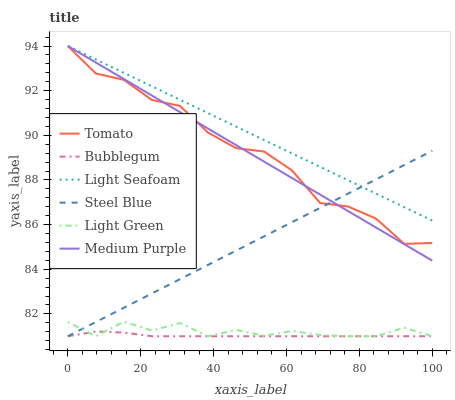Does Bubblegum have the minimum area under the curve?
Answer yes or no. Yes. Does Light Seafoam have the maximum area under the curve?
Answer yes or no. Yes. Does Steel Blue have the minimum area under the curve?
Answer yes or no. No. Does Steel Blue have the maximum area under the curve?
Answer yes or no. No. Is Steel Blue the smoothest?
Answer yes or no. Yes. Is Tomato the roughest?
Answer yes or no. Yes. Is Bubblegum the smoothest?
Answer yes or no. No. Is Bubblegum the roughest?
Answer yes or no. No. Does Medium Purple have the lowest value?
Answer yes or no. No. Does Light Seafoam have the highest value?
Answer yes or no. Yes. Does Steel Blue have the highest value?
Answer yes or no. No. Is Light Green less than Light Seafoam?
Answer yes or no. Yes. Is Tomato greater than Light Green?
Answer yes or no. Yes. Does Light Green intersect Steel Blue?
Answer yes or no. Yes. Is Light Green less than Steel Blue?
Answer yes or no. No. Is Light Green greater than Steel Blue?
Answer yes or no. No. Does Light Green intersect Light Seafoam?
Answer yes or no. No. 